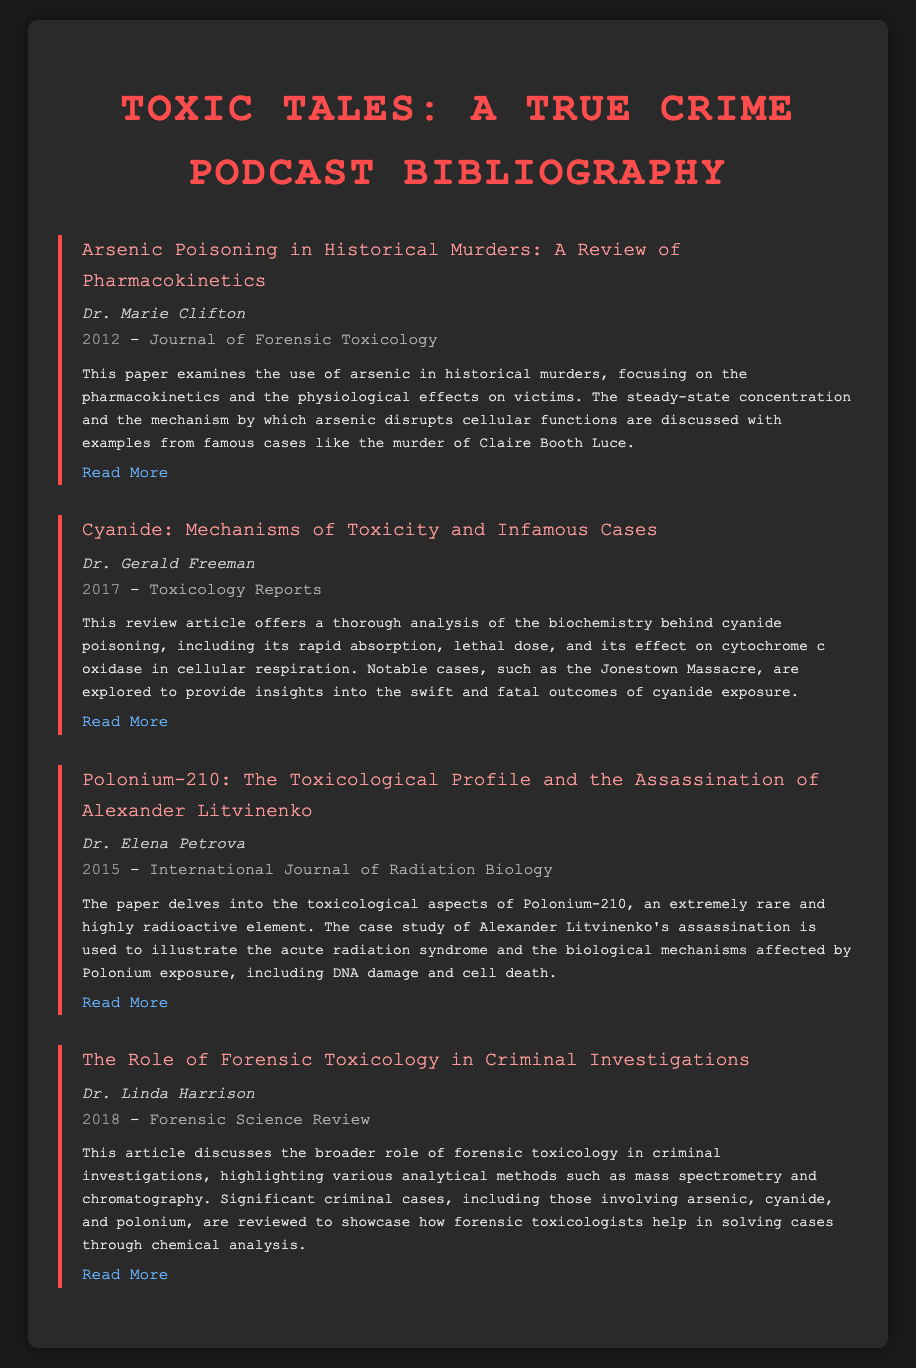What is the title of the paper by Dr. Marie Clifton? The title is found under her name in the bibliography section and is "Arsenic Poisoning in Historical Murders: A Review of Pharmacokinetics."
Answer: Arsenic Poisoning in Historical Murders: A Review of Pharmacokinetics Who authored the paper on cyanide poisoning? The author's name is listed below the title of the cyanide-related paper, which is Dr. Gerald Freeman.
Answer: Dr. Gerald Freeman What year was the article by Dr. Elena Petrova published? The year of publication is mentioned next to the author's name in the bibliography item and is 2015.
Answer: 2015 Which journal published the paper by Dr. Linda Harrison? The journal information appears next to the year and is "Forensic Science Review."
Answer: Forensic Science Review What common poison is discussed in the article about Alexander Litvinenko's assassination? The poison is highlighted in the title of the bibliography item and is Polonium-210.
Answer: Polonium-210 How many bibliography items focus on arsenic? By reviewing the document, it is clear there is one bibliography item specifically focusing on arsenic.
Answer: One What is the primary focus of the article written by Dr. Gerald Freeman? The focus is detailed in the abstract, emphasizing the mechanisms of cyanide toxicity and notable criminal cases.
Answer: Mechanisms of cyanide toxicity Which case study is associated with the research on Polonium-210? The case study involving this toxin is identified in the title and is the assassination of Alexander Litvinenko.
Answer: Assassination of Alexander Litvinenko 